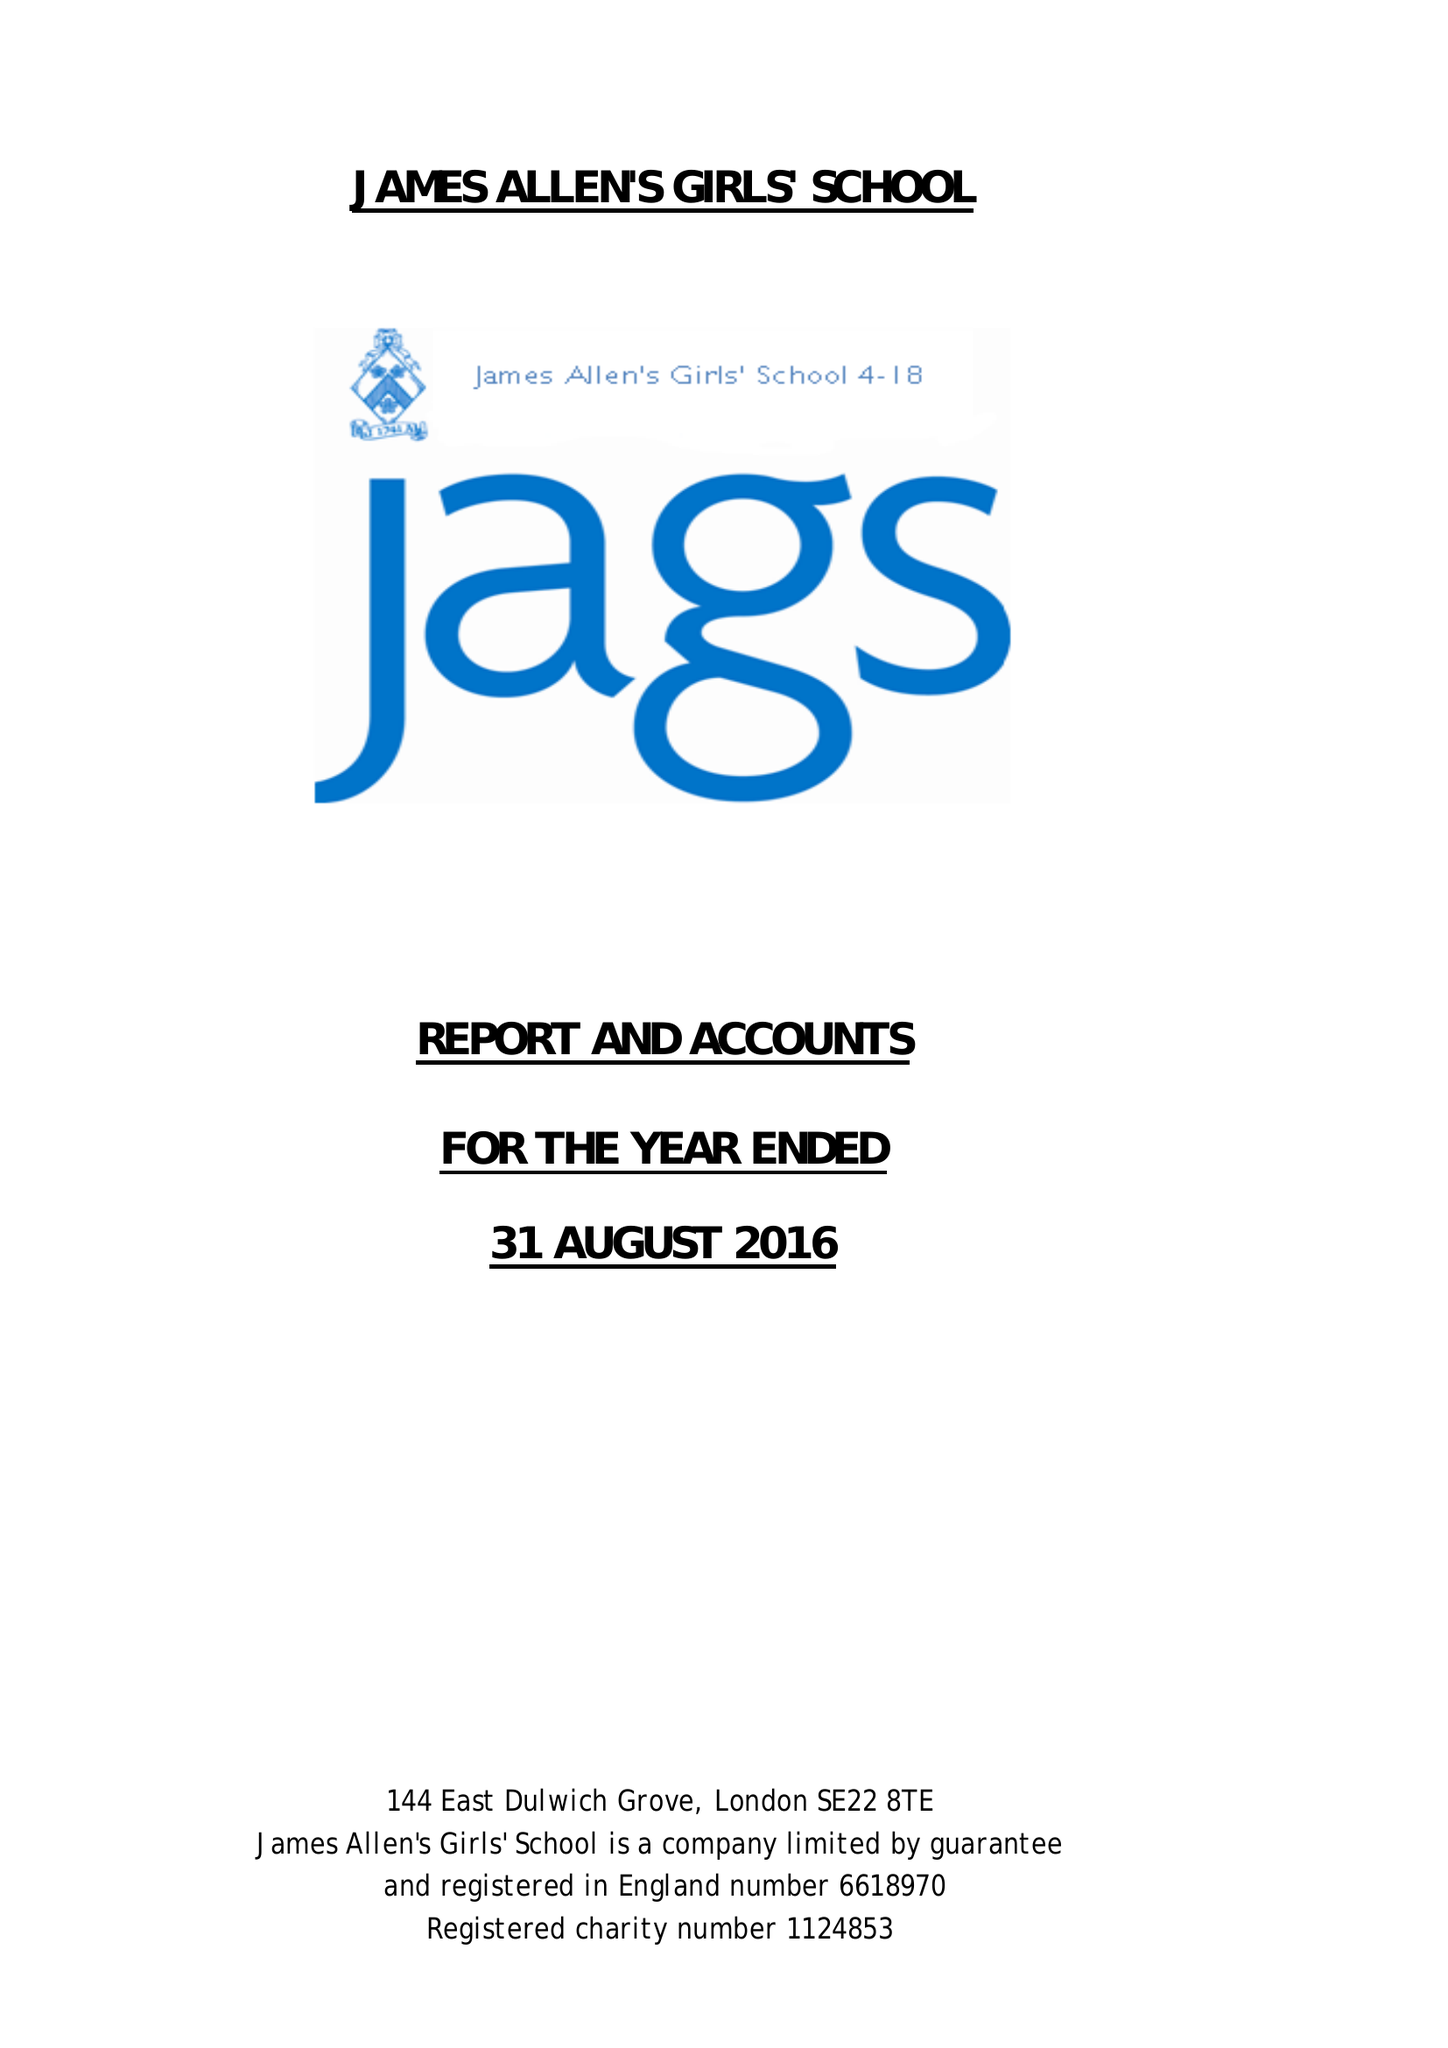What is the value for the spending_annually_in_british_pounds?
Answer the question using a single word or phrase. 18613186.00 